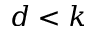Convert formula to latex. <formula><loc_0><loc_0><loc_500><loc_500>d < k</formula> 